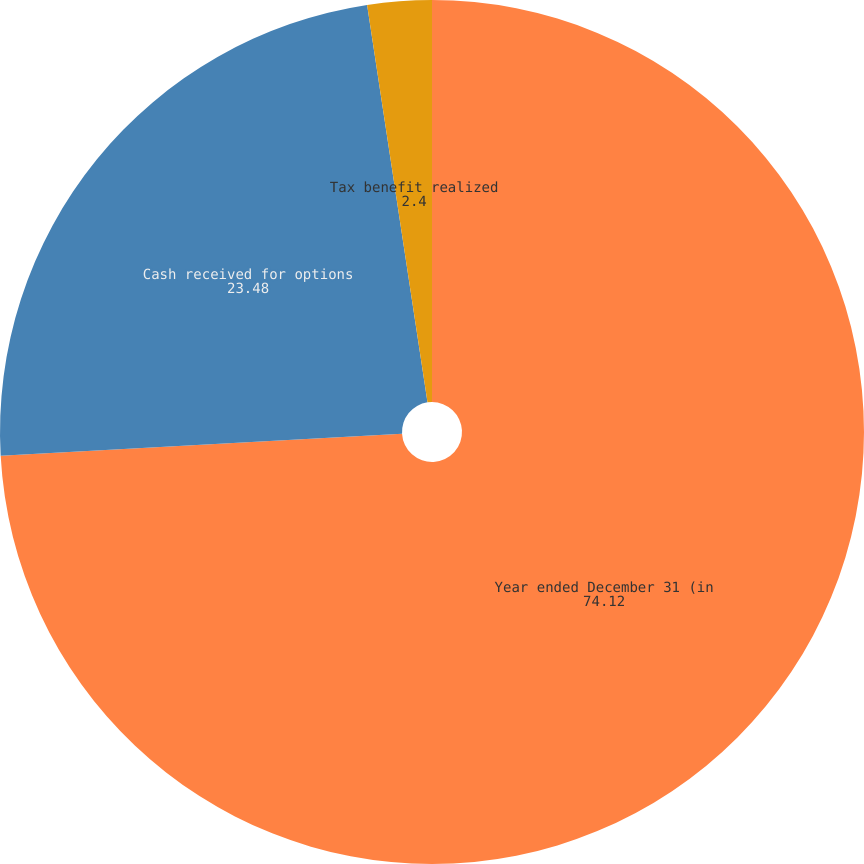Convert chart to OTSL. <chart><loc_0><loc_0><loc_500><loc_500><pie_chart><fcel>Year ended December 31 (in<fcel>Cash received for options<fcel>Tax benefit realized<nl><fcel>74.12%<fcel>23.48%<fcel>2.4%<nl></chart> 